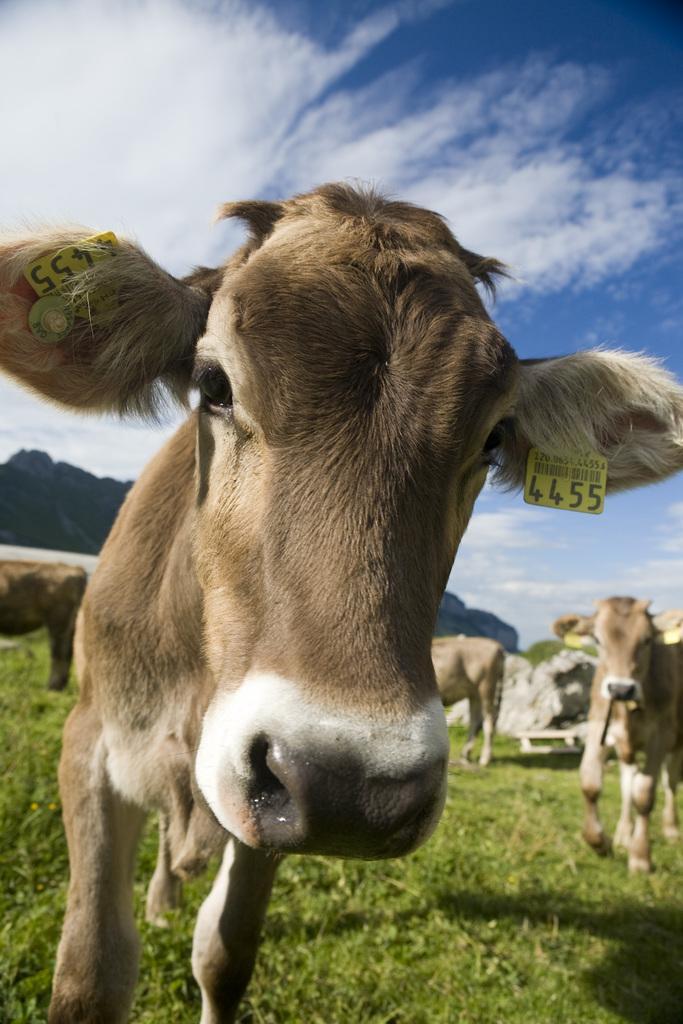Describe this image in one or two sentences. In this image I can see a cow in the center of the image with tags in his ears. I can see other cows behind on a ground and mountains behind them. At the top of the image I can see the sky. 